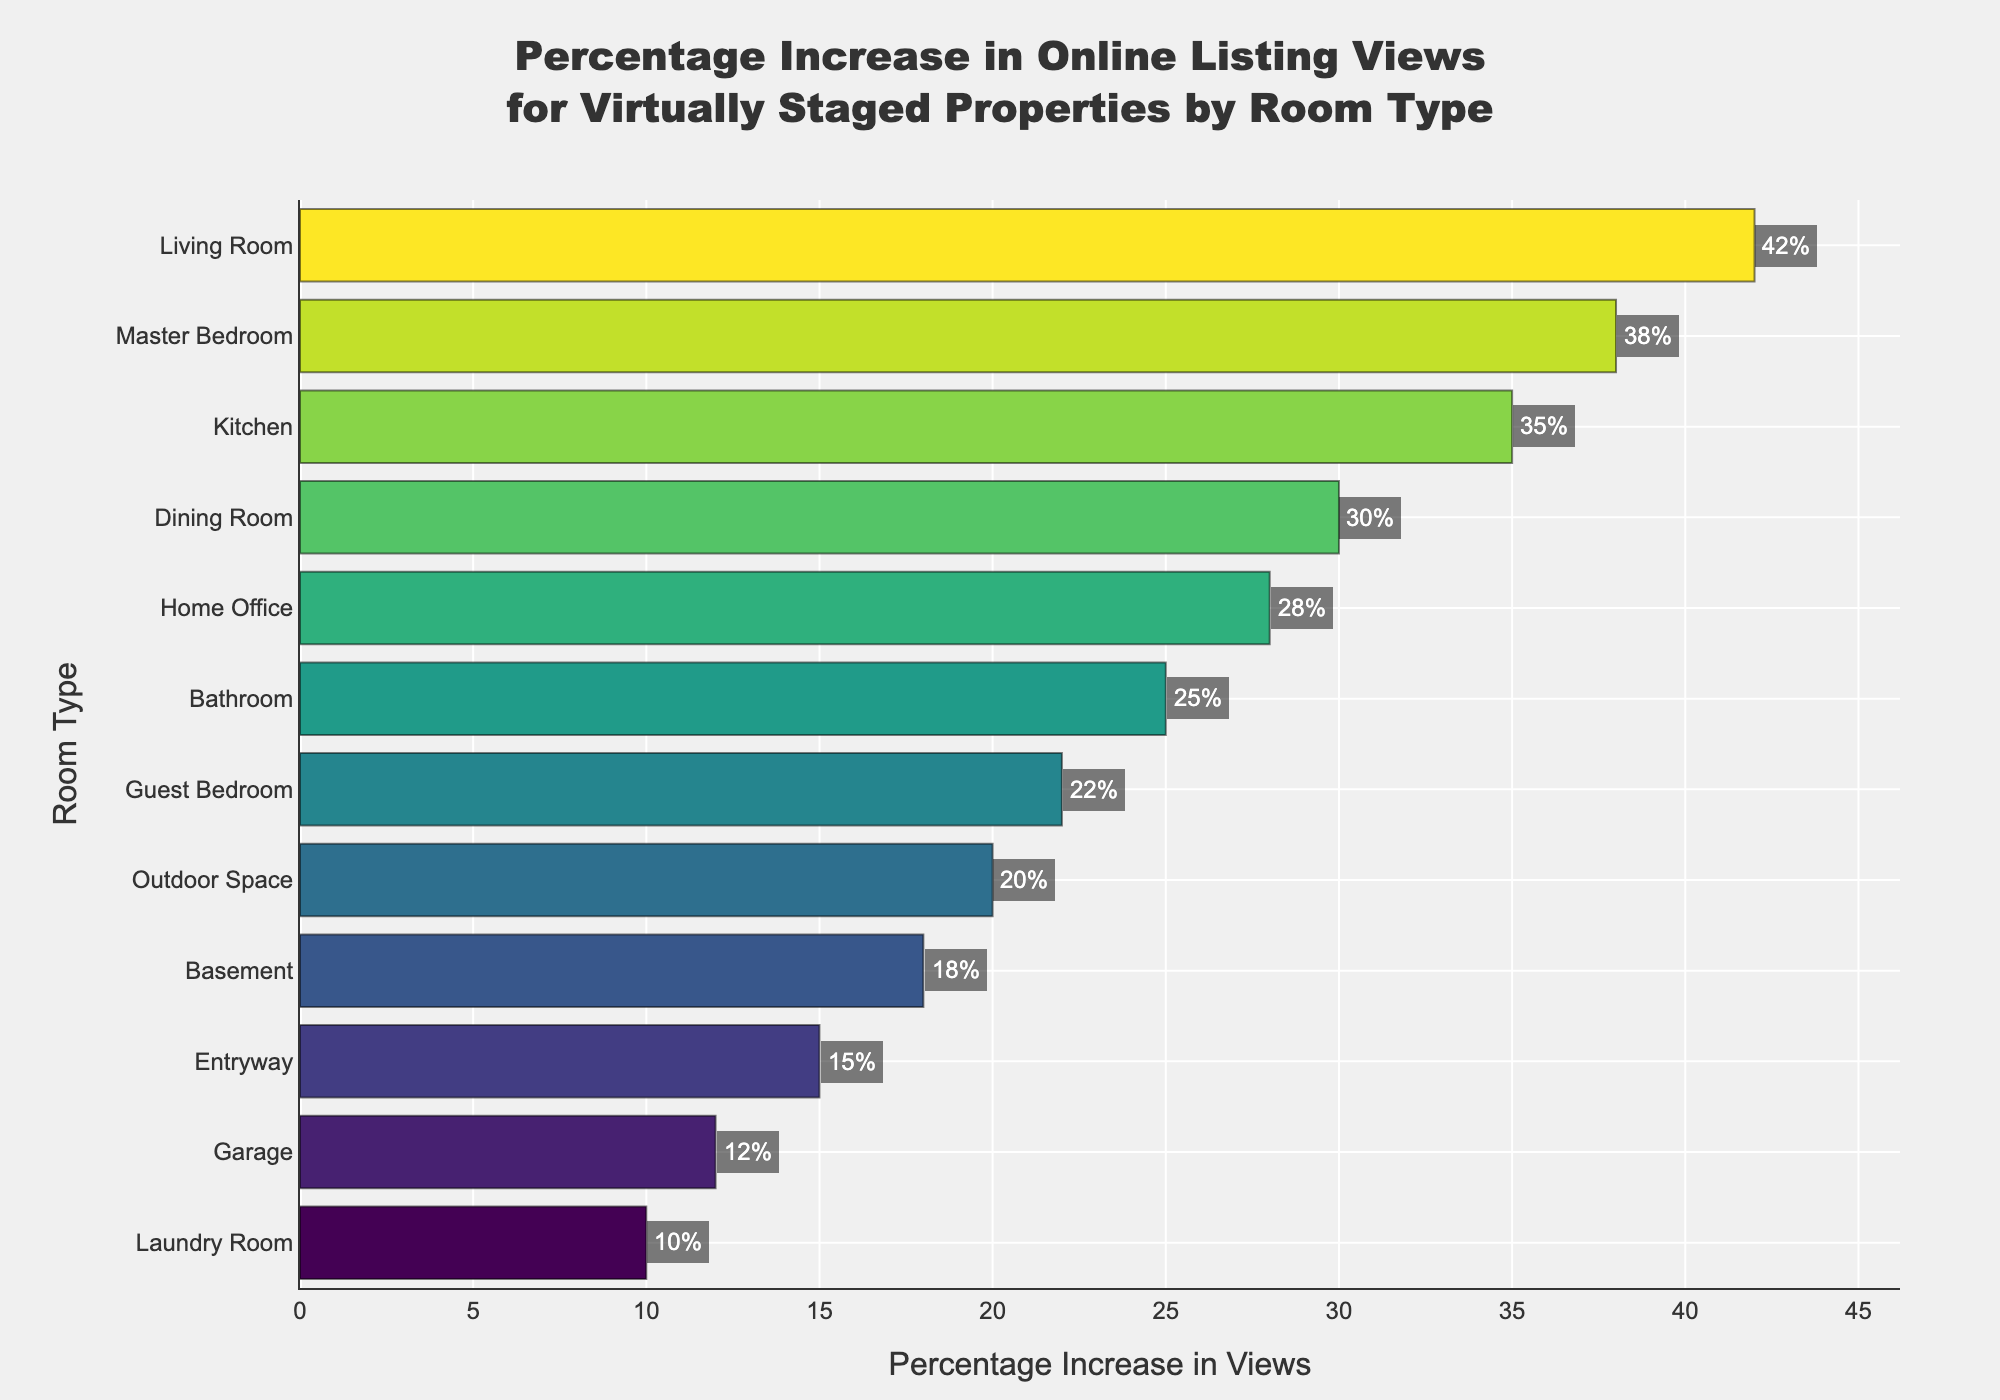Which room type has the highest percentage increase in online listing views? The room type with the highest percentage increase in online listing views has the tallest bar in the chart. The Living Room has the tallest bar, indicating a 42% increase.
Answer: Living Room Which room type has the lowest percentage increase in online listing views? The room type with the lowest percentage increase in online listing views has the shortest bar in the chart. The Laundry Room has the shortest bar, indicating a 10% increase.
Answer: Laundry Room What is the average percentage increase in views of the Home Office and the Bathroom? The percentage increase in views for the Home Office is 28% and for the Bathroom is 25%. The average is calculated as (28 + 25) / 2 = 26.5%.
Answer: 26.5% Is the percentage increase in views of the Master Bedroom greater than that of the Dining Room? By how much? The bar for the Master Bedroom shows a 38% increase, while the bar for the Dining Room shows a 30% increase. The difference is 38 - 30 = 8%.
Answer: 8% Which room type shows a greater percentage increase in views, the Guest Bedroom or the Dining Room? The bar for the Guest Bedroom shows a 22% increase, while the bar for the Dining Room shows a 30% increase. The Dining Room has a greater increase.
Answer: Dining Room How much higher is the percentage increase in views for the Kitchen compared to the Outdoor Space? The Kitchen has a 35% increase, while the Outdoor Space shows a 20% increase. The difference is 35 - 20 = 15%.
Answer: 15% Which room types have a percentage increase in views that is less than 20%? The room types with bars representing an increase of less than 20% are the Basement, Entryway, Garage, and Laundry Room, with respective increases of 18%, 15%, 12%, and 10%.
Answer: Basement, Entryway, Garage, Laundry Room Which rooms have a percentage increase in views between 20% and 30%? The room types with bars representing an increase between 20% and 30% are the Dining Room, Home Office, Bathroom, and Guest Bedroom, with respective increases of 30%, 28%, 25%, and 22%.
Answer: Dining Room, Home Office, Bathroom, Guest Bedroom 